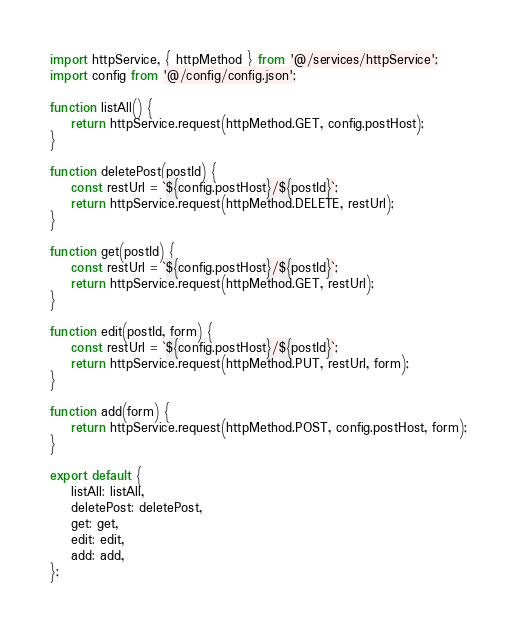<code> <loc_0><loc_0><loc_500><loc_500><_JavaScript_>import httpService, { httpMethod } from '@/services/httpService';
import config from '@/config/config.json';

function listAll() {
	return httpService.request(httpMethod.GET, config.postHost);
}

function deletePost(postId) {
	const restUrl = `${config.postHost}/${postId}`;
	return httpService.request(httpMethod.DELETE, restUrl);
}

function get(postId) {
	const restUrl = `${config.postHost}/${postId}`;
	return httpService.request(httpMethod.GET, restUrl);
}

function edit(postId, form) {
	const restUrl = `${config.postHost}/${postId}`;
	return httpService.request(httpMethod.PUT, restUrl, form);
}

function add(form) {
	return httpService.request(httpMethod.POST, config.postHost, form);
}

export default {
	listAll: listAll,
	deletePost: deletePost,
	get: get,
	edit: edit,
	add: add,
};
</code> 